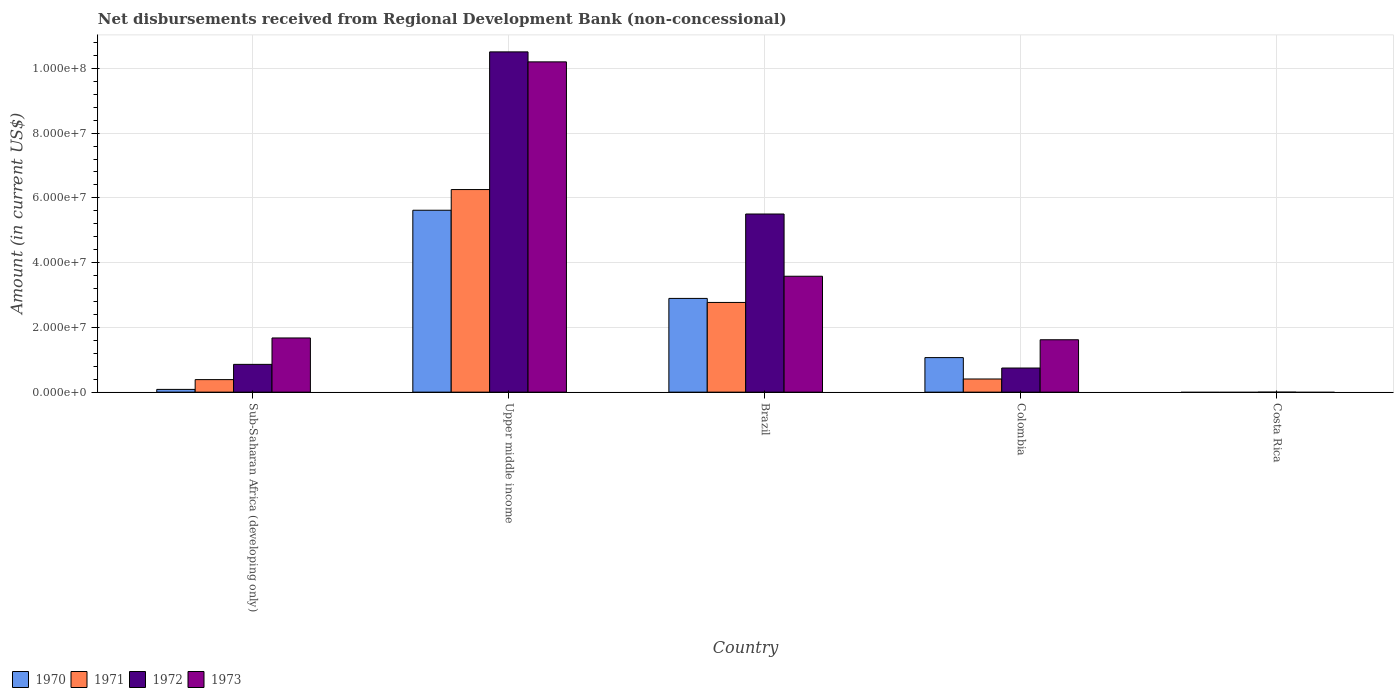Are the number of bars per tick equal to the number of legend labels?
Ensure brevity in your answer.  No. Are the number of bars on each tick of the X-axis equal?
Provide a short and direct response. No. How many bars are there on the 1st tick from the right?
Provide a succinct answer. 0. What is the label of the 1st group of bars from the left?
Provide a short and direct response. Sub-Saharan Africa (developing only). In how many cases, is the number of bars for a given country not equal to the number of legend labels?
Give a very brief answer. 1. What is the amount of disbursements received from Regional Development Bank in 1972 in Sub-Saharan Africa (developing only)?
Make the answer very short. 8.58e+06. Across all countries, what is the maximum amount of disbursements received from Regional Development Bank in 1972?
Your response must be concise. 1.05e+08. Across all countries, what is the minimum amount of disbursements received from Regional Development Bank in 1971?
Offer a very short reply. 0. In which country was the amount of disbursements received from Regional Development Bank in 1970 maximum?
Your response must be concise. Upper middle income. What is the total amount of disbursements received from Regional Development Bank in 1973 in the graph?
Your answer should be compact. 1.71e+08. What is the difference between the amount of disbursements received from Regional Development Bank in 1973 in Brazil and that in Colombia?
Give a very brief answer. 1.96e+07. What is the difference between the amount of disbursements received from Regional Development Bank in 1971 in Costa Rica and the amount of disbursements received from Regional Development Bank in 1970 in Colombia?
Give a very brief answer. -1.07e+07. What is the average amount of disbursements received from Regional Development Bank in 1973 per country?
Provide a short and direct response. 3.41e+07. What is the difference between the amount of disbursements received from Regional Development Bank of/in 1971 and amount of disbursements received from Regional Development Bank of/in 1970 in Sub-Saharan Africa (developing only)?
Keep it short and to the point. 3.02e+06. What is the ratio of the amount of disbursements received from Regional Development Bank in 1973 in Colombia to that in Upper middle income?
Ensure brevity in your answer.  0.16. What is the difference between the highest and the second highest amount of disbursements received from Regional Development Bank in 1973?
Provide a succinct answer. 8.53e+07. What is the difference between the highest and the lowest amount of disbursements received from Regional Development Bank in 1970?
Ensure brevity in your answer.  5.62e+07. In how many countries, is the amount of disbursements received from Regional Development Bank in 1970 greater than the average amount of disbursements received from Regional Development Bank in 1970 taken over all countries?
Provide a succinct answer. 2. Is the sum of the amount of disbursements received from Regional Development Bank in 1971 in Brazil and Colombia greater than the maximum amount of disbursements received from Regional Development Bank in 1970 across all countries?
Your answer should be compact. No. Is it the case that in every country, the sum of the amount of disbursements received from Regional Development Bank in 1973 and amount of disbursements received from Regional Development Bank in 1971 is greater than the amount of disbursements received from Regional Development Bank in 1970?
Your answer should be very brief. No. Are all the bars in the graph horizontal?
Offer a very short reply. No. How many countries are there in the graph?
Your response must be concise. 5. Are the values on the major ticks of Y-axis written in scientific E-notation?
Your response must be concise. Yes. Does the graph contain any zero values?
Keep it short and to the point. Yes. Where does the legend appear in the graph?
Ensure brevity in your answer.  Bottom left. How are the legend labels stacked?
Ensure brevity in your answer.  Horizontal. What is the title of the graph?
Provide a succinct answer. Net disbursements received from Regional Development Bank (non-concessional). Does "1979" appear as one of the legend labels in the graph?
Provide a short and direct response. No. What is the label or title of the X-axis?
Offer a terse response. Country. What is the Amount (in current US$) of 1970 in Sub-Saharan Africa (developing only)?
Provide a short and direct response. 8.50e+05. What is the Amount (in current US$) in 1971 in Sub-Saharan Africa (developing only)?
Ensure brevity in your answer.  3.87e+06. What is the Amount (in current US$) of 1972 in Sub-Saharan Africa (developing only)?
Provide a short and direct response. 8.58e+06. What is the Amount (in current US$) of 1973 in Sub-Saharan Africa (developing only)?
Your response must be concise. 1.67e+07. What is the Amount (in current US$) in 1970 in Upper middle income?
Your response must be concise. 5.62e+07. What is the Amount (in current US$) of 1971 in Upper middle income?
Keep it short and to the point. 6.26e+07. What is the Amount (in current US$) in 1972 in Upper middle income?
Make the answer very short. 1.05e+08. What is the Amount (in current US$) in 1973 in Upper middle income?
Provide a short and direct response. 1.02e+08. What is the Amount (in current US$) of 1970 in Brazil?
Make the answer very short. 2.90e+07. What is the Amount (in current US$) in 1971 in Brazil?
Make the answer very short. 2.77e+07. What is the Amount (in current US$) in 1972 in Brazil?
Make the answer very short. 5.50e+07. What is the Amount (in current US$) in 1973 in Brazil?
Provide a short and direct response. 3.58e+07. What is the Amount (in current US$) of 1970 in Colombia?
Keep it short and to the point. 1.07e+07. What is the Amount (in current US$) of 1971 in Colombia?
Offer a terse response. 4.06e+06. What is the Amount (in current US$) of 1972 in Colombia?
Provide a short and direct response. 7.45e+06. What is the Amount (in current US$) in 1973 in Colombia?
Provide a short and direct response. 1.62e+07. What is the Amount (in current US$) in 1970 in Costa Rica?
Ensure brevity in your answer.  0. What is the Amount (in current US$) of 1972 in Costa Rica?
Give a very brief answer. 0. What is the Amount (in current US$) in 1973 in Costa Rica?
Offer a terse response. 0. Across all countries, what is the maximum Amount (in current US$) in 1970?
Your answer should be compact. 5.62e+07. Across all countries, what is the maximum Amount (in current US$) of 1971?
Ensure brevity in your answer.  6.26e+07. Across all countries, what is the maximum Amount (in current US$) in 1972?
Keep it short and to the point. 1.05e+08. Across all countries, what is the maximum Amount (in current US$) in 1973?
Your response must be concise. 1.02e+08. Across all countries, what is the minimum Amount (in current US$) in 1970?
Your answer should be very brief. 0. Across all countries, what is the minimum Amount (in current US$) of 1971?
Your response must be concise. 0. Across all countries, what is the minimum Amount (in current US$) of 1973?
Your response must be concise. 0. What is the total Amount (in current US$) in 1970 in the graph?
Your answer should be compact. 9.67e+07. What is the total Amount (in current US$) of 1971 in the graph?
Provide a short and direct response. 9.82e+07. What is the total Amount (in current US$) in 1972 in the graph?
Your answer should be compact. 1.76e+08. What is the total Amount (in current US$) in 1973 in the graph?
Offer a very short reply. 1.71e+08. What is the difference between the Amount (in current US$) of 1970 in Sub-Saharan Africa (developing only) and that in Upper middle income?
Ensure brevity in your answer.  -5.53e+07. What is the difference between the Amount (in current US$) in 1971 in Sub-Saharan Africa (developing only) and that in Upper middle income?
Your answer should be compact. -5.87e+07. What is the difference between the Amount (in current US$) of 1972 in Sub-Saharan Africa (developing only) and that in Upper middle income?
Your answer should be very brief. -9.65e+07. What is the difference between the Amount (in current US$) of 1973 in Sub-Saharan Africa (developing only) and that in Upper middle income?
Your response must be concise. -8.53e+07. What is the difference between the Amount (in current US$) of 1970 in Sub-Saharan Africa (developing only) and that in Brazil?
Your answer should be very brief. -2.81e+07. What is the difference between the Amount (in current US$) of 1971 in Sub-Saharan Africa (developing only) and that in Brazil?
Your response must be concise. -2.38e+07. What is the difference between the Amount (in current US$) in 1972 in Sub-Saharan Africa (developing only) and that in Brazil?
Your response must be concise. -4.64e+07. What is the difference between the Amount (in current US$) in 1973 in Sub-Saharan Africa (developing only) and that in Brazil?
Your answer should be very brief. -1.91e+07. What is the difference between the Amount (in current US$) of 1970 in Sub-Saharan Africa (developing only) and that in Colombia?
Your response must be concise. -9.82e+06. What is the difference between the Amount (in current US$) in 1971 in Sub-Saharan Africa (developing only) and that in Colombia?
Keep it short and to the point. -1.93e+05. What is the difference between the Amount (in current US$) of 1972 in Sub-Saharan Africa (developing only) and that in Colombia?
Your answer should be compact. 1.13e+06. What is the difference between the Amount (in current US$) of 1973 in Sub-Saharan Africa (developing only) and that in Colombia?
Your answer should be very brief. 5.57e+05. What is the difference between the Amount (in current US$) of 1970 in Upper middle income and that in Brazil?
Your answer should be very brief. 2.72e+07. What is the difference between the Amount (in current US$) in 1971 in Upper middle income and that in Brazil?
Give a very brief answer. 3.49e+07. What is the difference between the Amount (in current US$) of 1972 in Upper middle income and that in Brazil?
Provide a short and direct response. 5.01e+07. What is the difference between the Amount (in current US$) of 1973 in Upper middle income and that in Brazil?
Provide a succinct answer. 6.62e+07. What is the difference between the Amount (in current US$) of 1970 in Upper middle income and that in Colombia?
Ensure brevity in your answer.  4.55e+07. What is the difference between the Amount (in current US$) in 1971 in Upper middle income and that in Colombia?
Provide a succinct answer. 5.85e+07. What is the difference between the Amount (in current US$) in 1972 in Upper middle income and that in Colombia?
Keep it short and to the point. 9.76e+07. What is the difference between the Amount (in current US$) in 1973 in Upper middle income and that in Colombia?
Provide a short and direct response. 8.58e+07. What is the difference between the Amount (in current US$) in 1970 in Brazil and that in Colombia?
Keep it short and to the point. 1.83e+07. What is the difference between the Amount (in current US$) in 1971 in Brazil and that in Colombia?
Your response must be concise. 2.36e+07. What is the difference between the Amount (in current US$) in 1972 in Brazil and that in Colombia?
Your answer should be very brief. 4.76e+07. What is the difference between the Amount (in current US$) of 1973 in Brazil and that in Colombia?
Make the answer very short. 1.96e+07. What is the difference between the Amount (in current US$) in 1970 in Sub-Saharan Africa (developing only) and the Amount (in current US$) in 1971 in Upper middle income?
Your answer should be compact. -6.17e+07. What is the difference between the Amount (in current US$) in 1970 in Sub-Saharan Africa (developing only) and the Amount (in current US$) in 1972 in Upper middle income?
Offer a terse response. -1.04e+08. What is the difference between the Amount (in current US$) in 1970 in Sub-Saharan Africa (developing only) and the Amount (in current US$) in 1973 in Upper middle income?
Keep it short and to the point. -1.01e+08. What is the difference between the Amount (in current US$) of 1971 in Sub-Saharan Africa (developing only) and the Amount (in current US$) of 1972 in Upper middle income?
Your answer should be compact. -1.01e+08. What is the difference between the Amount (in current US$) in 1971 in Sub-Saharan Africa (developing only) and the Amount (in current US$) in 1973 in Upper middle income?
Your answer should be very brief. -9.81e+07. What is the difference between the Amount (in current US$) of 1972 in Sub-Saharan Africa (developing only) and the Amount (in current US$) of 1973 in Upper middle income?
Offer a very short reply. -9.34e+07. What is the difference between the Amount (in current US$) of 1970 in Sub-Saharan Africa (developing only) and the Amount (in current US$) of 1971 in Brazil?
Make the answer very short. -2.69e+07. What is the difference between the Amount (in current US$) in 1970 in Sub-Saharan Africa (developing only) and the Amount (in current US$) in 1972 in Brazil?
Your response must be concise. -5.42e+07. What is the difference between the Amount (in current US$) of 1970 in Sub-Saharan Africa (developing only) and the Amount (in current US$) of 1973 in Brazil?
Give a very brief answer. -3.50e+07. What is the difference between the Amount (in current US$) of 1971 in Sub-Saharan Africa (developing only) and the Amount (in current US$) of 1972 in Brazil?
Make the answer very short. -5.12e+07. What is the difference between the Amount (in current US$) in 1971 in Sub-Saharan Africa (developing only) and the Amount (in current US$) in 1973 in Brazil?
Provide a short and direct response. -3.19e+07. What is the difference between the Amount (in current US$) in 1972 in Sub-Saharan Africa (developing only) and the Amount (in current US$) in 1973 in Brazil?
Offer a terse response. -2.72e+07. What is the difference between the Amount (in current US$) in 1970 in Sub-Saharan Africa (developing only) and the Amount (in current US$) in 1971 in Colombia?
Ensure brevity in your answer.  -3.21e+06. What is the difference between the Amount (in current US$) in 1970 in Sub-Saharan Africa (developing only) and the Amount (in current US$) in 1972 in Colombia?
Ensure brevity in your answer.  -6.60e+06. What is the difference between the Amount (in current US$) in 1970 in Sub-Saharan Africa (developing only) and the Amount (in current US$) in 1973 in Colombia?
Provide a succinct answer. -1.53e+07. What is the difference between the Amount (in current US$) in 1971 in Sub-Saharan Africa (developing only) and the Amount (in current US$) in 1972 in Colombia?
Offer a very short reply. -3.58e+06. What is the difference between the Amount (in current US$) in 1971 in Sub-Saharan Africa (developing only) and the Amount (in current US$) in 1973 in Colombia?
Your response must be concise. -1.23e+07. What is the difference between the Amount (in current US$) in 1972 in Sub-Saharan Africa (developing only) and the Amount (in current US$) in 1973 in Colombia?
Ensure brevity in your answer.  -7.60e+06. What is the difference between the Amount (in current US$) in 1970 in Upper middle income and the Amount (in current US$) in 1971 in Brazil?
Your response must be concise. 2.85e+07. What is the difference between the Amount (in current US$) of 1970 in Upper middle income and the Amount (in current US$) of 1972 in Brazil?
Your answer should be very brief. 1.16e+06. What is the difference between the Amount (in current US$) of 1970 in Upper middle income and the Amount (in current US$) of 1973 in Brazil?
Offer a very short reply. 2.04e+07. What is the difference between the Amount (in current US$) in 1971 in Upper middle income and the Amount (in current US$) in 1972 in Brazil?
Make the answer very short. 7.55e+06. What is the difference between the Amount (in current US$) in 1971 in Upper middle income and the Amount (in current US$) in 1973 in Brazil?
Offer a very short reply. 2.68e+07. What is the difference between the Amount (in current US$) of 1972 in Upper middle income and the Amount (in current US$) of 1973 in Brazil?
Provide a succinct answer. 6.93e+07. What is the difference between the Amount (in current US$) in 1970 in Upper middle income and the Amount (in current US$) in 1971 in Colombia?
Your answer should be very brief. 5.21e+07. What is the difference between the Amount (in current US$) in 1970 in Upper middle income and the Amount (in current US$) in 1972 in Colombia?
Make the answer very short. 4.87e+07. What is the difference between the Amount (in current US$) of 1970 in Upper middle income and the Amount (in current US$) of 1973 in Colombia?
Offer a very short reply. 4.00e+07. What is the difference between the Amount (in current US$) in 1971 in Upper middle income and the Amount (in current US$) in 1972 in Colombia?
Ensure brevity in your answer.  5.51e+07. What is the difference between the Amount (in current US$) in 1971 in Upper middle income and the Amount (in current US$) in 1973 in Colombia?
Ensure brevity in your answer.  4.64e+07. What is the difference between the Amount (in current US$) of 1972 in Upper middle income and the Amount (in current US$) of 1973 in Colombia?
Ensure brevity in your answer.  8.89e+07. What is the difference between the Amount (in current US$) in 1970 in Brazil and the Amount (in current US$) in 1971 in Colombia?
Provide a short and direct response. 2.49e+07. What is the difference between the Amount (in current US$) in 1970 in Brazil and the Amount (in current US$) in 1972 in Colombia?
Make the answer very short. 2.15e+07. What is the difference between the Amount (in current US$) of 1970 in Brazil and the Amount (in current US$) of 1973 in Colombia?
Provide a succinct answer. 1.28e+07. What is the difference between the Amount (in current US$) in 1971 in Brazil and the Amount (in current US$) in 1972 in Colombia?
Make the answer very short. 2.03e+07. What is the difference between the Amount (in current US$) of 1971 in Brazil and the Amount (in current US$) of 1973 in Colombia?
Offer a very short reply. 1.15e+07. What is the difference between the Amount (in current US$) of 1972 in Brazil and the Amount (in current US$) of 1973 in Colombia?
Your response must be concise. 3.88e+07. What is the average Amount (in current US$) of 1970 per country?
Provide a short and direct response. 1.93e+07. What is the average Amount (in current US$) of 1971 per country?
Your answer should be compact. 1.96e+07. What is the average Amount (in current US$) of 1972 per country?
Keep it short and to the point. 3.52e+07. What is the average Amount (in current US$) of 1973 per country?
Ensure brevity in your answer.  3.41e+07. What is the difference between the Amount (in current US$) of 1970 and Amount (in current US$) of 1971 in Sub-Saharan Africa (developing only)?
Provide a short and direct response. -3.02e+06. What is the difference between the Amount (in current US$) in 1970 and Amount (in current US$) in 1972 in Sub-Saharan Africa (developing only)?
Offer a terse response. -7.73e+06. What is the difference between the Amount (in current US$) of 1970 and Amount (in current US$) of 1973 in Sub-Saharan Africa (developing only)?
Provide a short and direct response. -1.59e+07. What is the difference between the Amount (in current US$) in 1971 and Amount (in current US$) in 1972 in Sub-Saharan Africa (developing only)?
Provide a succinct answer. -4.71e+06. What is the difference between the Amount (in current US$) of 1971 and Amount (in current US$) of 1973 in Sub-Saharan Africa (developing only)?
Keep it short and to the point. -1.29e+07. What is the difference between the Amount (in current US$) in 1972 and Amount (in current US$) in 1973 in Sub-Saharan Africa (developing only)?
Make the answer very short. -8.16e+06. What is the difference between the Amount (in current US$) of 1970 and Amount (in current US$) of 1971 in Upper middle income?
Ensure brevity in your answer.  -6.39e+06. What is the difference between the Amount (in current US$) in 1970 and Amount (in current US$) in 1972 in Upper middle income?
Your answer should be compact. -4.89e+07. What is the difference between the Amount (in current US$) in 1970 and Amount (in current US$) in 1973 in Upper middle income?
Keep it short and to the point. -4.58e+07. What is the difference between the Amount (in current US$) of 1971 and Amount (in current US$) of 1972 in Upper middle income?
Give a very brief answer. -4.25e+07. What is the difference between the Amount (in current US$) in 1971 and Amount (in current US$) in 1973 in Upper middle income?
Provide a succinct answer. -3.94e+07. What is the difference between the Amount (in current US$) in 1972 and Amount (in current US$) in 1973 in Upper middle income?
Provide a short and direct response. 3.08e+06. What is the difference between the Amount (in current US$) in 1970 and Amount (in current US$) in 1971 in Brazil?
Give a very brief answer. 1.25e+06. What is the difference between the Amount (in current US$) in 1970 and Amount (in current US$) in 1972 in Brazil?
Provide a succinct answer. -2.61e+07. What is the difference between the Amount (in current US$) in 1970 and Amount (in current US$) in 1973 in Brazil?
Offer a terse response. -6.85e+06. What is the difference between the Amount (in current US$) of 1971 and Amount (in current US$) of 1972 in Brazil?
Offer a very short reply. -2.73e+07. What is the difference between the Amount (in current US$) of 1971 and Amount (in current US$) of 1973 in Brazil?
Your answer should be very brief. -8.10e+06. What is the difference between the Amount (in current US$) of 1972 and Amount (in current US$) of 1973 in Brazil?
Provide a succinct answer. 1.92e+07. What is the difference between the Amount (in current US$) of 1970 and Amount (in current US$) of 1971 in Colombia?
Offer a very short reply. 6.61e+06. What is the difference between the Amount (in current US$) of 1970 and Amount (in current US$) of 1972 in Colombia?
Keep it short and to the point. 3.22e+06. What is the difference between the Amount (in current US$) in 1970 and Amount (in current US$) in 1973 in Colombia?
Make the answer very short. -5.51e+06. What is the difference between the Amount (in current US$) in 1971 and Amount (in current US$) in 1972 in Colombia?
Your answer should be compact. -3.39e+06. What is the difference between the Amount (in current US$) of 1971 and Amount (in current US$) of 1973 in Colombia?
Offer a very short reply. -1.21e+07. What is the difference between the Amount (in current US$) of 1972 and Amount (in current US$) of 1973 in Colombia?
Give a very brief answer. -8.73e+06. What is the ratio of the Amount (in current US$) in 1970 in Sub-Saharan Africa (developing only) to that in Upper middle income?
Give a very brief answer. 0.02. What is the ratio of the Amount (in current US$) of 1971 in Sub-Saharan Africa (developing only) to that in Upper middle income?
Offer a terse response. 0.06. What is the ratio of the Amount (in current US$) in 1972 in Sub-Saharan Africa (developing only) to that in Upper middle income?
Give a very brief answer. 0.08. What is the ratio of the Amount (in current US$) in 1973 in Sub-Saharan Africa (developing only) to that in Upper middle income?
Your response must be concise. 0.16. What is the ratio of the Amount (in current US$) in 1970 in Sub-Saharan Africa (developing only) to that in Brazil?
Your answer should be compact. 0.03. What is the ratio of the Amount (in current US$) of 1971 in Sub-Saharan Africa (developing only) to that in Brazil?
Offer a very short reply. 0.14. What is the ratio of the Amount (in current US$) in 1972 in Sub-Saharan Africa (developing only) to that in Brazil?
Give a very brief answer. 0.16. What is the ratio of the Amount (in current US$) of 1973 in Sub-Saharan Africa (developing only) to that in Brazil?
Offer a terse response. 0.47. What is the ratio of the Amount (in current US$) in 1970 in Sub-Saharan Africa (developing only) to that in Colombia?
Your answer should be very brief. 0.08. What is the ratio of the Amount (in current US$) in 1971 in Sub-Saharan Africa (developing only) to that in Colombia?
Your answer should be compact. 0.95. What is the ratio of the Amount (in current US$) in 1972 in Sub-Saharan Africa (developing only) to that in Colombia?
Your answer should be compact. 1.15. What is the ratio of the Amount (in current US$) of 1973 in Sub-Saharan Africa (developing only) to that in Colombia?
Your response must be concise. 1.03. What is the ratio of the Amount (in current US$) of 1970 in Upper middle income to that in Brazil?
Offer a very short reply. 1.94. What is the ratio of the Amount (in current US$) in 1971 in Upper middle income to that in Brazil?
Keep it short and to the point. 2.26. What is the ratio of the Amount (in current US$) in 1972 in Upper middle income to that in Brazil?
Your response must be concise. 1.91. What is the ratio of the Amount (in current US$) of 1973 in Upper middle income to that in Brazil?
Your response must be concise. 2.85. What is the ratio of the Amount (in current US$) in 1970 in Upper middle income to that in Colombia?
Offer a terse response. 5.27. What is the ratio of the Amount (in current US$) of 1971 in Upper middle income to that in Colombia?
Your answer should be compact. 15.4. What is the ratio of the Amount (in current US$) in 1972 in Upper middle income to that in Colombia?
Your answer should be compact. 14.11. What is the ratio of the Amount (in current US$) in 1973 in Upper middle income to that in Colombia?
Your answer should be compact. 6.3. What is the ratio of the Amount (in current US$) of 1970 in Brazil to that in Colombia?
Your answer should be compact. 2.71. What is the ratio of the Amount (in current US$) in 1971 in Brazil to that in Colombia?
Make the answer very short. 6.82. What is the ratio of the Amount (in current US$) of 1972 in Brazil to that in Colombia?
Your answer should be very brief. 7.39. What is the ratio of the Amount (in current US$) of 1973 in Brazil to that in Colombia?
Provide a succinct answer. 2.21. What is the difference between the highest and the second highest Amount (in current US$) of 1970?
Keep it short and to the point. 2.72e+07. What is the difference between the highest and the second highest Amount (in current US$) in 1971?
Offer a very short reply. 3.49e+07. What is the difference between the highest and the second highest Amount (in current US$) of 1972?
Offer a very short reply. 5.01e+07. What is the difference between the highest and the second highest Amount (in current US$) in 1973?
Your answer should be compact. 6.62e+07. What is the difference between the highest and the lowest Amount (in current US$) in 1970?
Keep it short and to the point. 5.62e+07. What is the difference between the highest and the lowest Amount (in current US$) of 1971?
Your answer should be very brief. 6.26e+07. What is the difference between the highest and the lowest Amount (in current US$) in 1972?
Give a very brief answer. 1.05e+08. What is the difference between the highest and the lowest Amount (in current US$) in 1973?
Provide a succinct answer. 1.02e+08. 